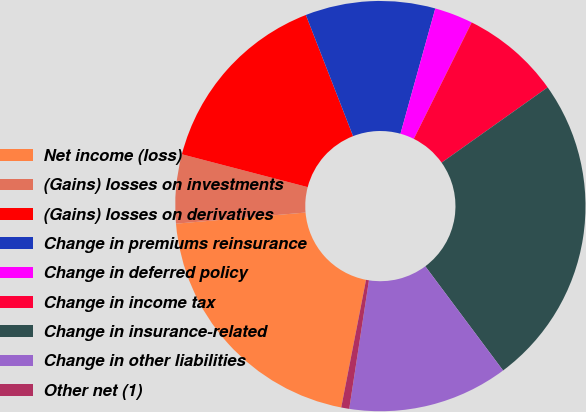<chart> <loc_0><loc_0><loc_500><loc_500><pie_chart><fcel>Net income (loss)<fcel>(Gains) losses on investments<fcel>(Gains) losses on derivatives<fcel>Change in premiums reinsurance<fcel>Change in deferred policy<fcel>Change in income tax<fcel>Change in insurance-related<fcel>Change in other liabilities<fcel>Other net (1)<nl><fcel>20.58%<fcel>5.43%<fcel>15.02%<fcel>10.23%<fcel>3.03%<fcel>7.83%<fcel>24.62%<fcel>12.63%<fcel>0.63%<nl></chart> 